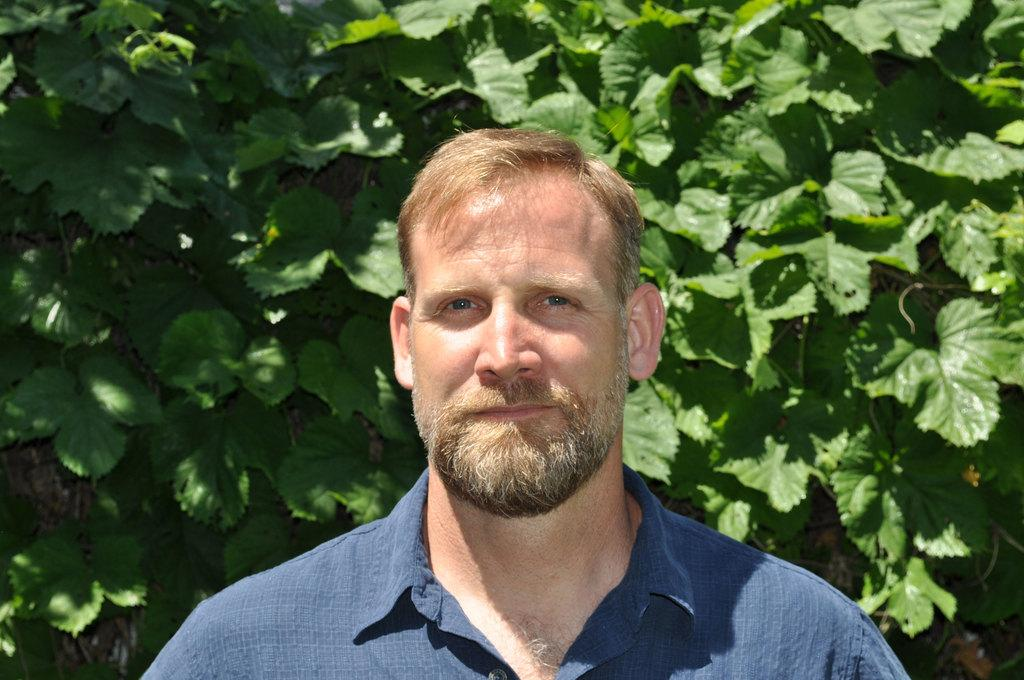What is present in the image? There is a man in the image. What is the man wearing? The man is wearing clothes. What can be seen in the background of the image? There are leaves in the background of the image. What curve can be seen in the image? There is no curve present in the image. What does the man represent in the image? The image does not indicate that the man represents anything specific. 